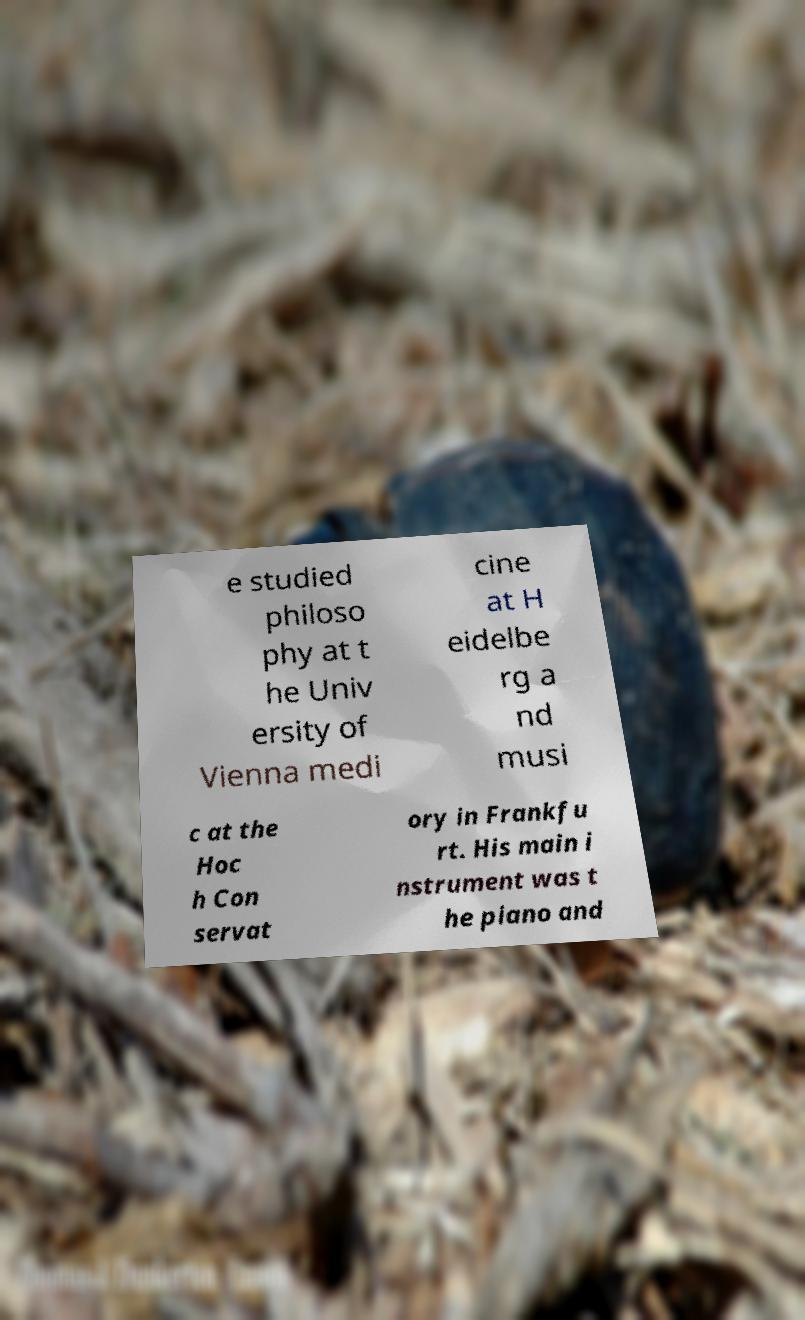Could you extract and type out the text from this image? e studied philoso phy at t he Univ ersity of Vienna medi cine at H eidelbe rg a nd musi c at the Hoc h Con servat ory in Frankfu rt. His main i nstrument was t he piano and 